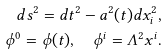<formula> <loc_0><loc_0><loc_500><loc_500>d s ^ { 2 } = d t ^ { 2 } - a ^ { 2 } ( t ) d x _ { i } ^ { 2 } , \\ \phi ^ { 0 } = \phi ( t ) , \quad \phi ^ { i } = \Lambda ^ { 2 } x ^ { i } .</formula> 